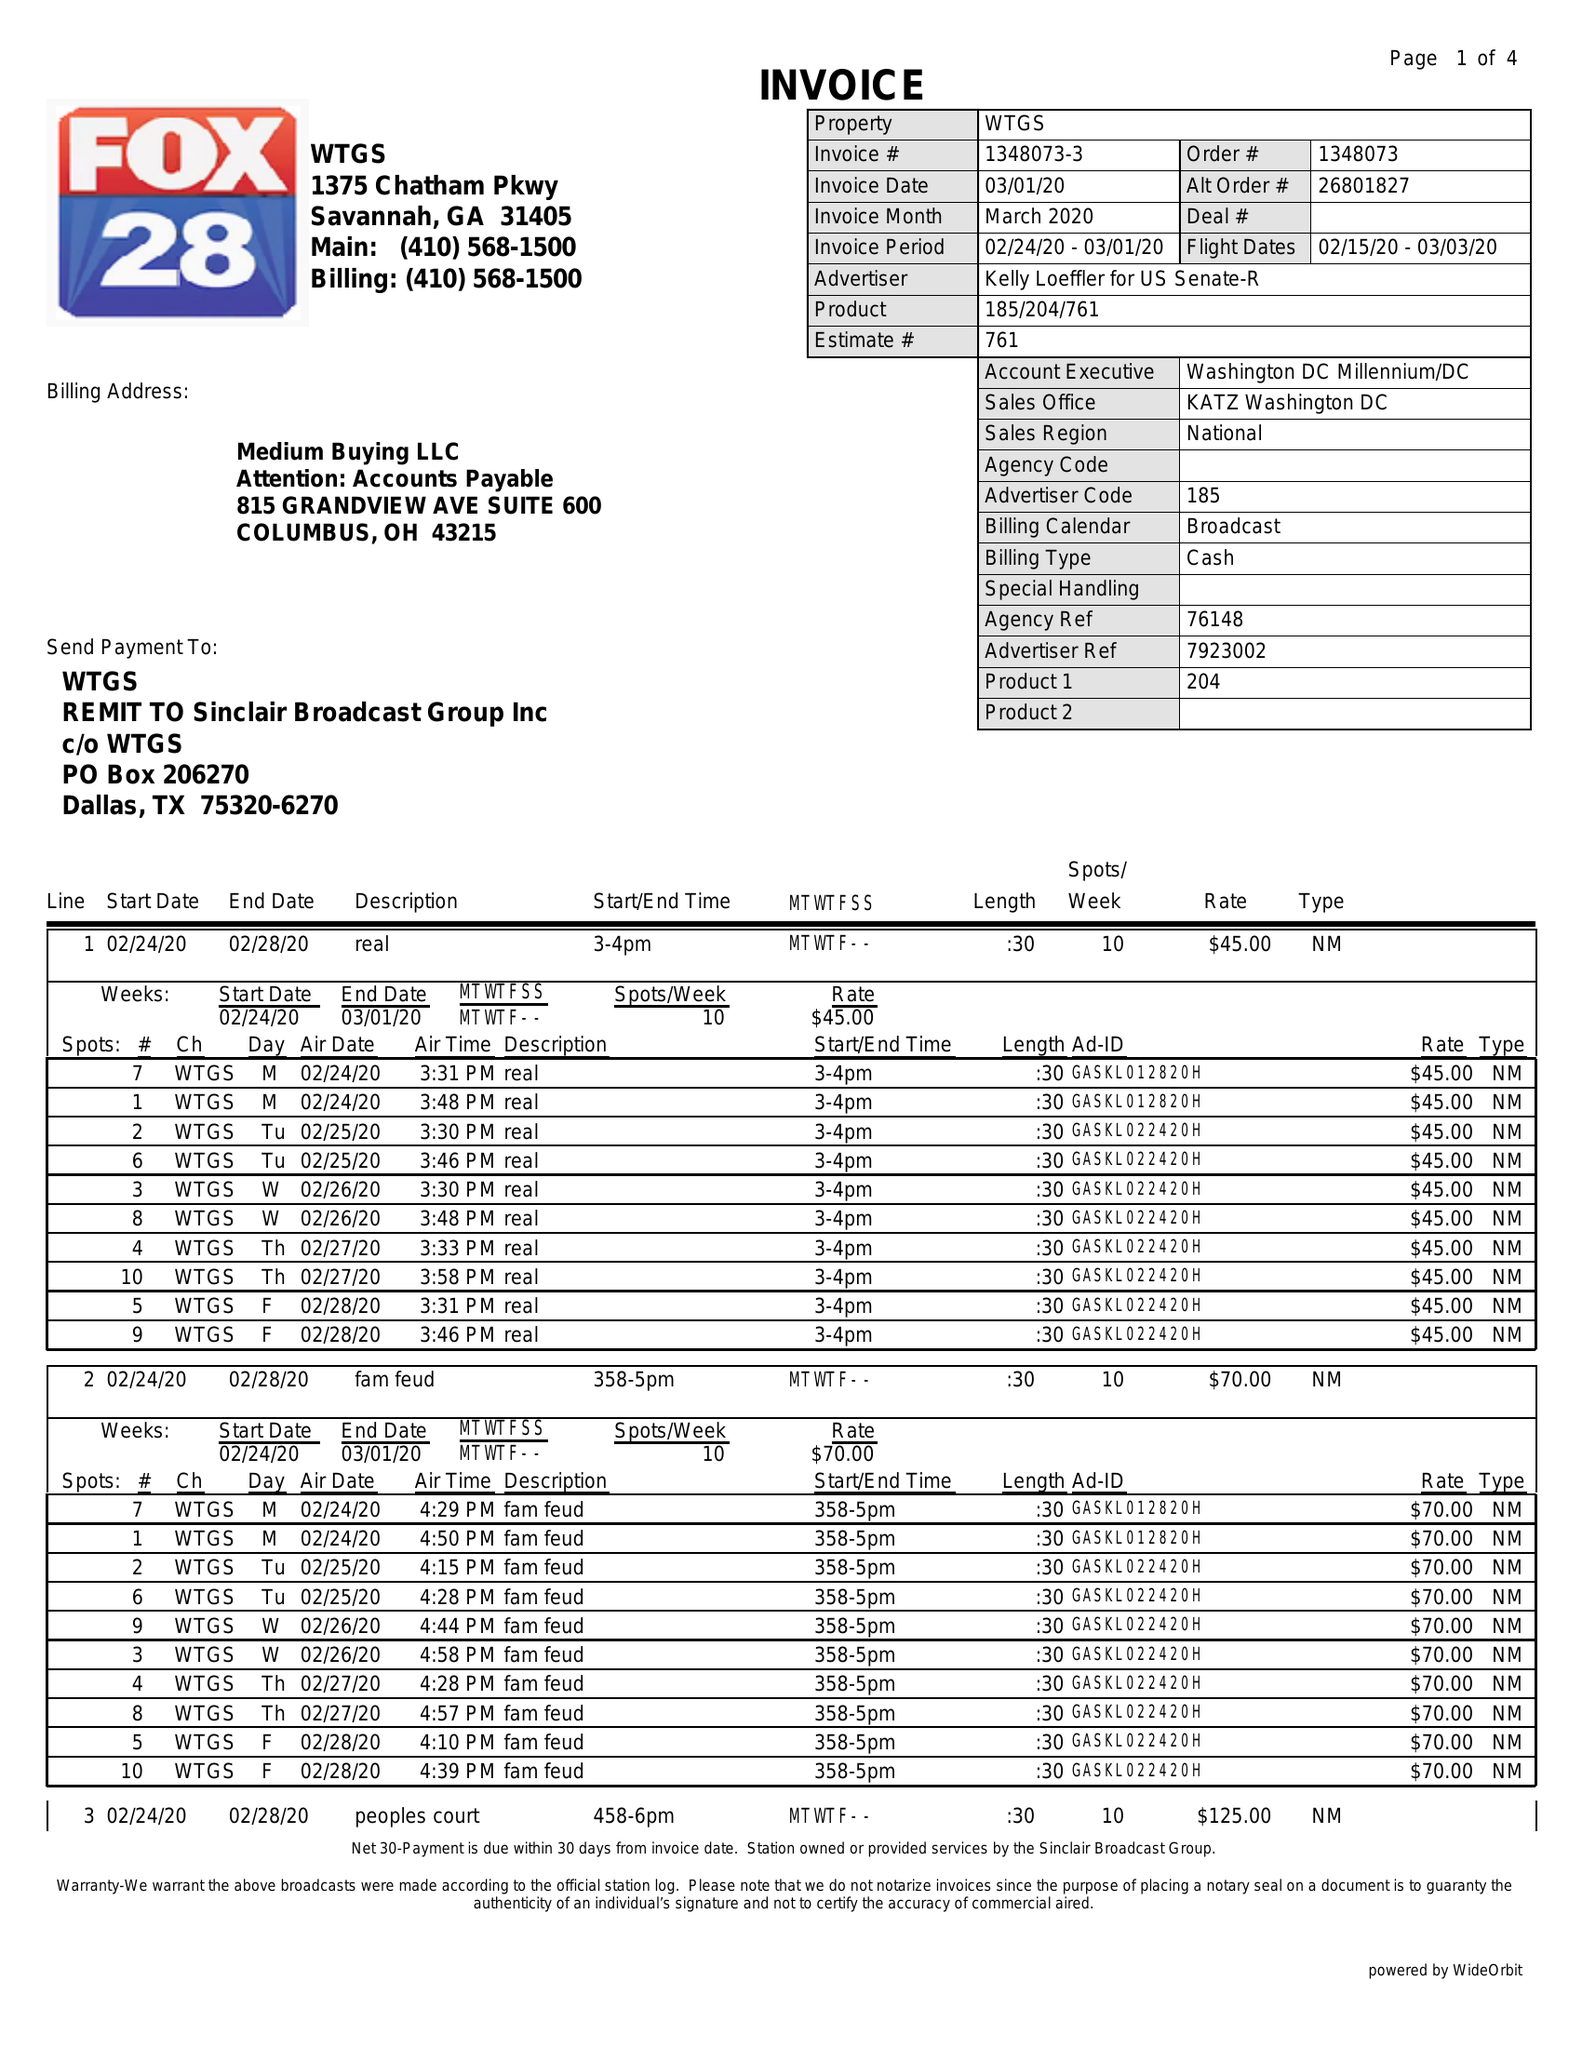What is the value for the flight_from?
Answer the question using a single word or phrase. 02/15/20 